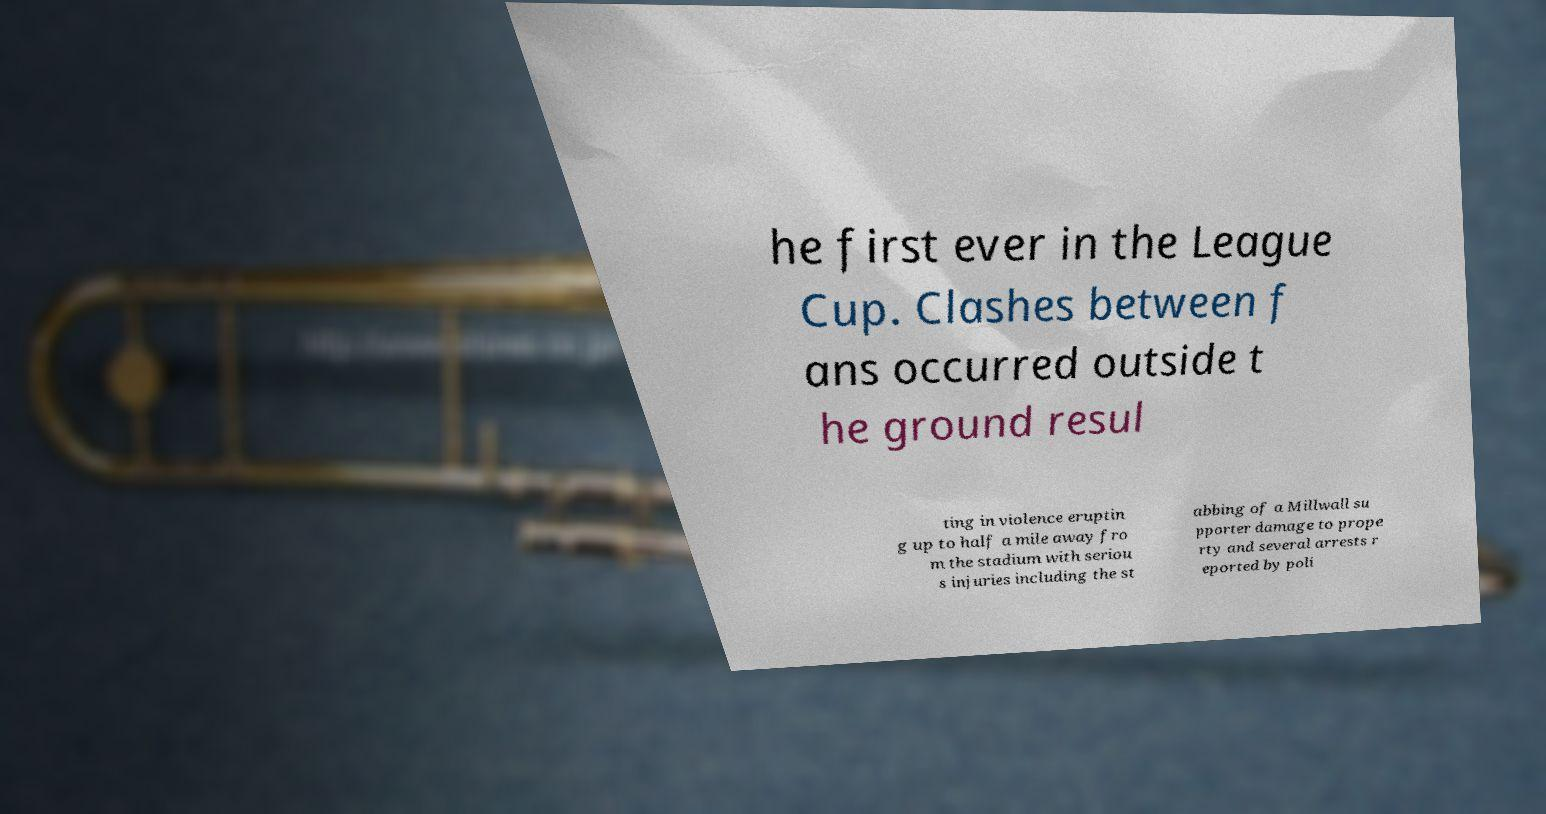What messages or text are displayed in this image? I need them in a readable, typed format. he first ever in the League Cup. Clashes between f ans occurred outside t he ground resul ting in violence eruptin g up to half a mile away fro m the stadium with seriou s injuries including the st abbing of a Millwall su pporter damage to prope rty and several arrests r eported by poli 